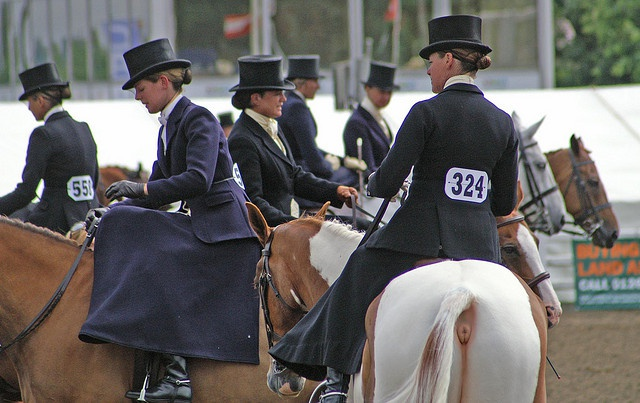Describe the objects in this image and their specific colors. I can see people in gray and black tones, people in gray, black, and darkblue tones, horse in gray, darkgray, and lightgray tones, horse in gray, brown, and black tones, and horse in gray, black, darkgray, and brown tones in this image. 